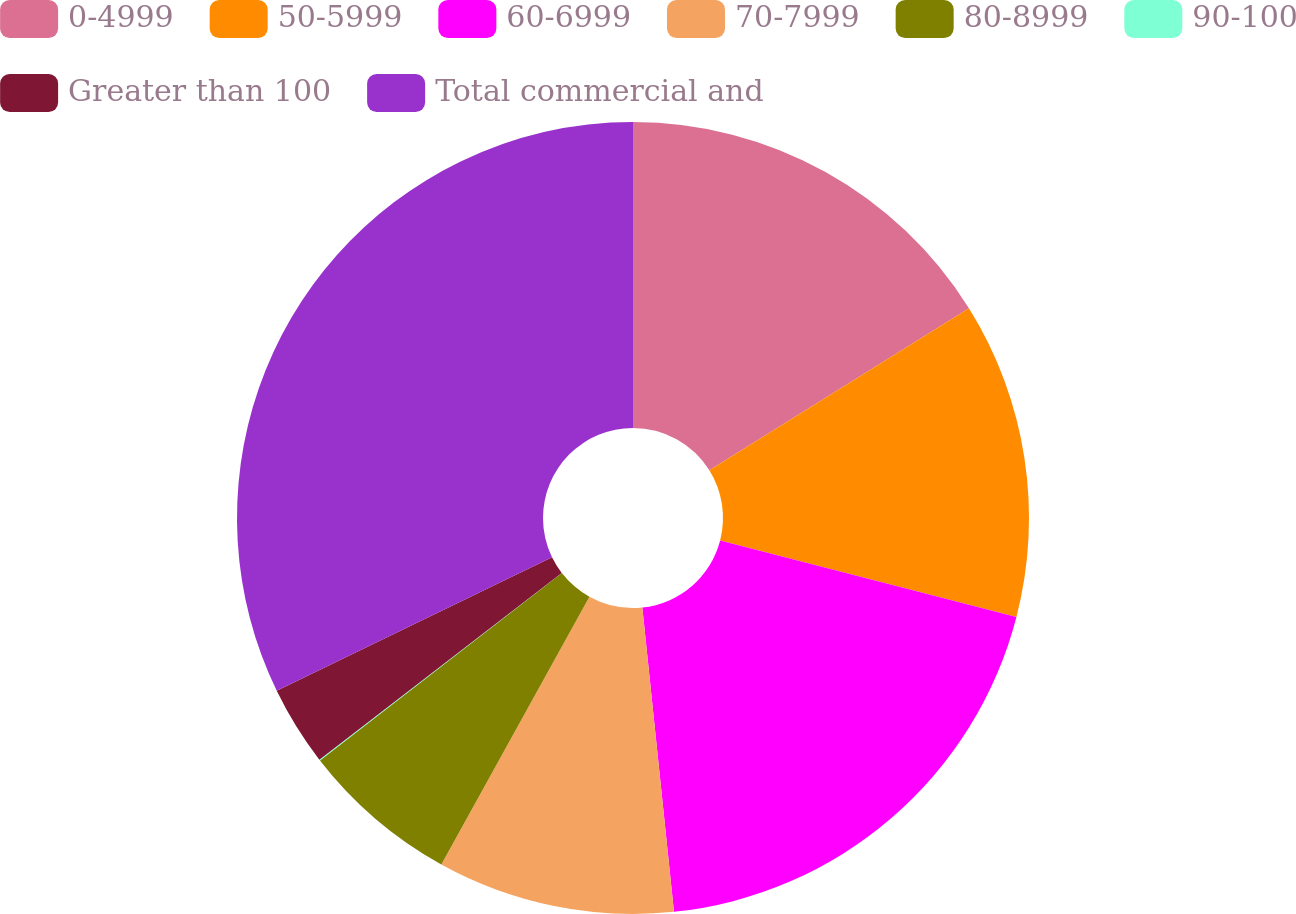Convert chart. <chart><loc_0><loc_0><loc_500><loc_500><pie_chart><fcel>0-4999<fcel>50-5999<fcel>60-6999<fcel>70-7999<fcel>80-8999<fcel>90-100<fcel>Greater than 100<fcel>Total commercial and<nl><fcel>16.12%<fcel>12.9%<fcel>19.33%<fcel>9.69%<fcel>6.47%<fcel>0.04%<fcel>3.26%<fcel>32.19%<nl></chart> 